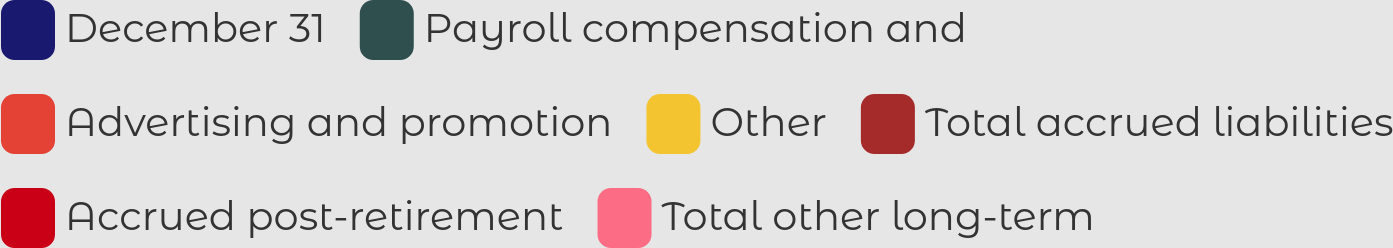Convert chart. <chart><loc_0><loc_0><loc_500><loc_500><pie_chart><fcel>December 31<fcel>Payroll compensation and<fcel>Advertising and promotion<fcel>Other<fcel>Total accrued liabilities<fcel>Accrued post-retirement<fcel>Total other long-term<nl><fcel>0.13%<fcel>9.55%<fcel>13.68%<fcel>6.62%<fcel>29.4%<fcel>16.61%<fcel>24.02%<nl></chart> 